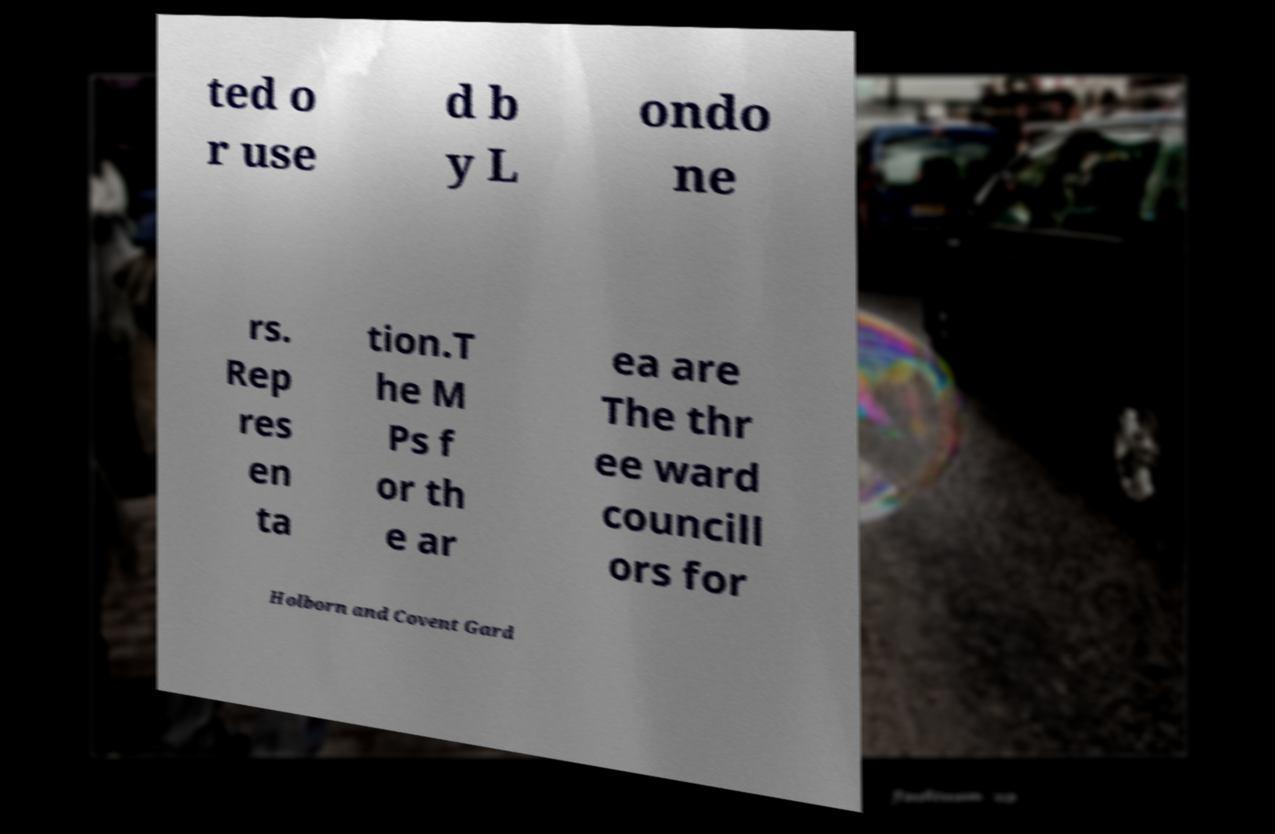There's text embedded in this image that I need extracted. Can you transcribe it verbatim? ted o r use d b y L ondo ne rs. Rep res en ta tion.T he M Ps f or th e ar ea are The thr ee ward councill ors for Holborn and Covent Gard 